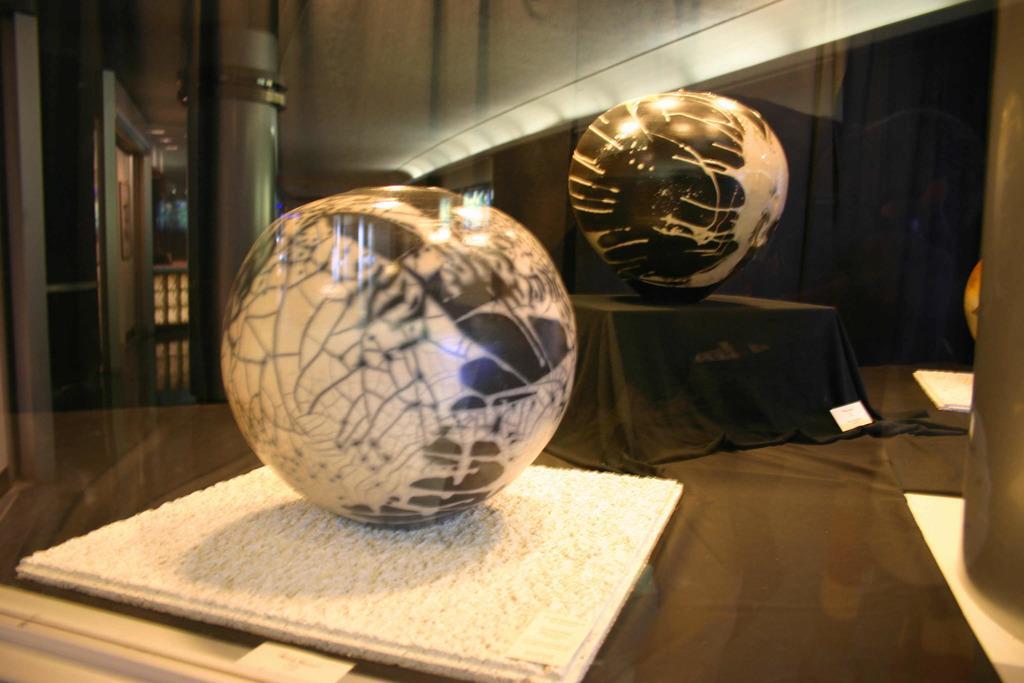Can you describe this image briefly? At the bottom of the image there is a table and we can see decors, cloth and a box placed on the table. In the background there is a pillar, door and a wall. 